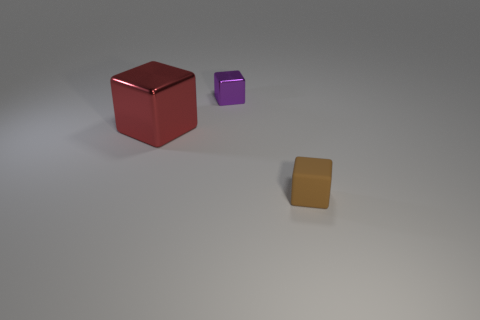Subtract all tiny cubes. How many cubes are left? 1 Add 3 big green metal spheres. How many objects exist? 6 Add 2 small things. How many small things exist? 4 Subtract 0 gray balls. How many objects are left? 3 Subtract all cyan blocks. Subtract all gray cylinders. How many blocks are left? 3 Subtract all small rubber cubes. Subtract all large red shiny objects. How many objects are left? 1 Add 2 small brown rubber cubes. How many small brown rubber cubes are left? 3 